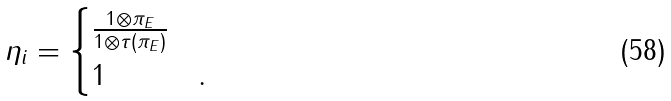Convert formula to latex. <formula><loc_0><loc_0><loc_500><loc_500>\eta _ { i } & = \begin{cases} \frac { 1 \otimes \pi _ { E } } { 1 \otimes \tau ( \pi _ { E } ) } & \\ 1 & . \end{cases}</formula> 